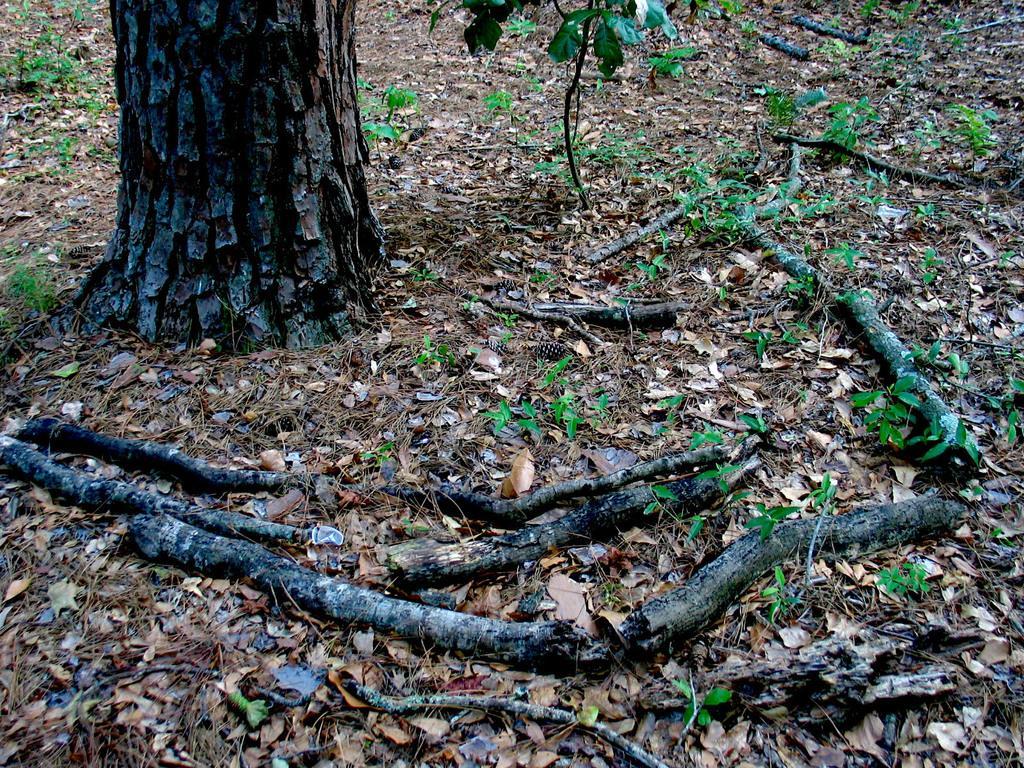In one or two sentences, can you explain what this image depicts? This image is clicked outside. There is a tree at the top. There are small plants in the middle. 